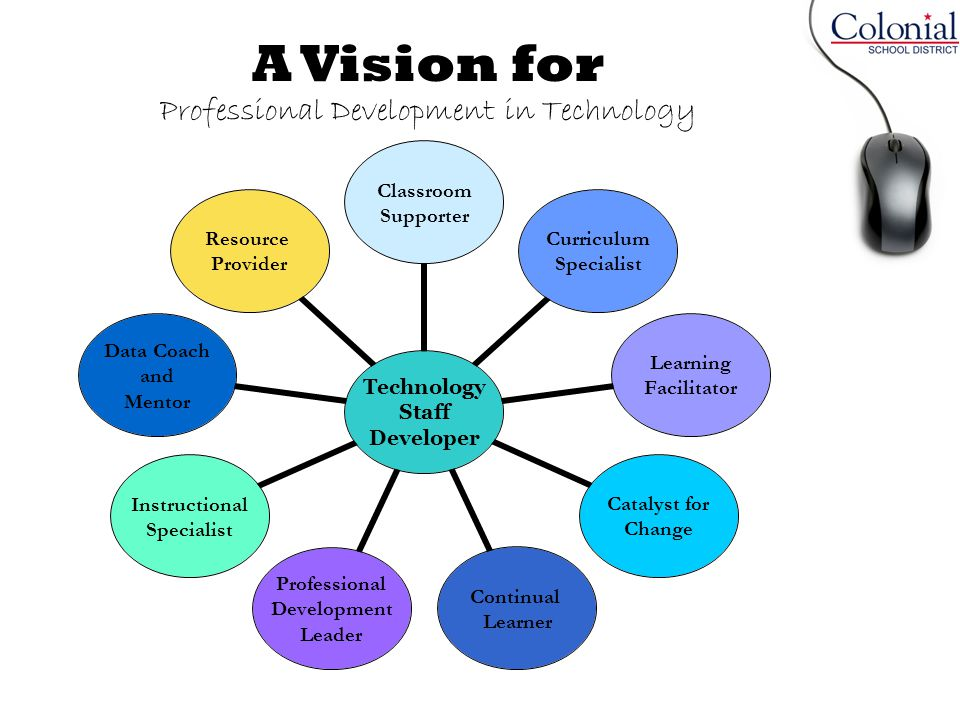Considering the logo present in the image, what organization might be associated with this vision for professional development, and how does the role of 'Curriculum Specialist' potentially align with the organization's goals? The logo in the top right corner of the image indicates that the Colonial School District is associated with this vision for professional development in technology. The role of the 'Curriculum Specialist' aligns closely with the organization's goals by focusing on integrating technology into the curriculum effectively. This role is critical in ensuring that educational content and teaching methodologies evolve to leverage technology, fostering a more interactive and engaging learning environment. By doing so, the Curriculum Specialist supports the overall objective of enhancing educational outcomes through the thoughtful application of technology. 